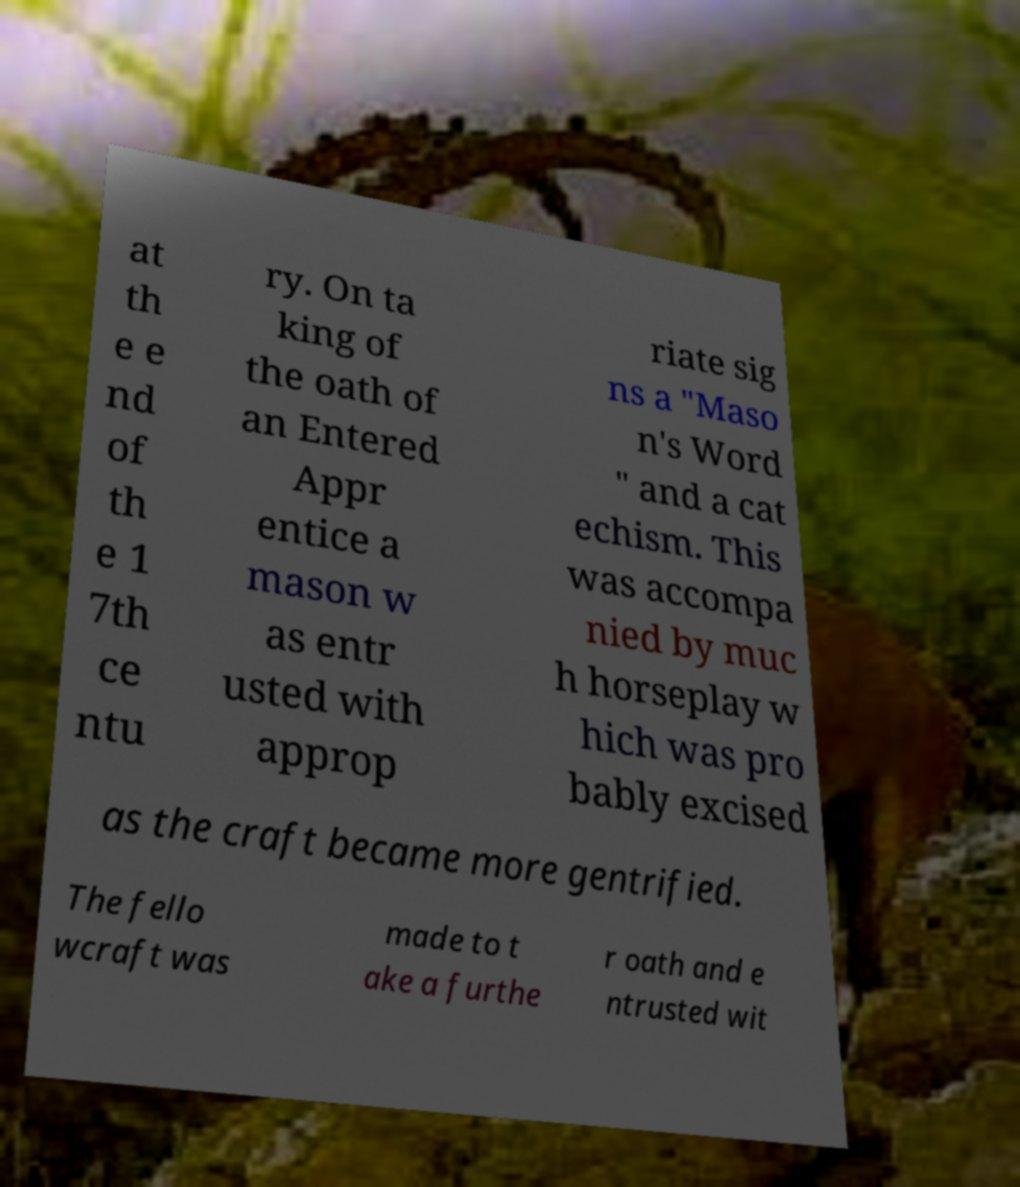What messages or text are displayed in this image? I need them in a readable, typed format. at th e e nd of th e 1 7th ce ntu ry. On ta king of the oath of an Entered Appr entice a mason w as entr usted with approp riate sig ns a "Maso n's Word " and a cat echism. This was accompa nied by muc h horseplay w hich was pro bably excised as the craft became more gentrified. The fello wcraft was made to t ake a furthe r oath and e ntrusted wit 